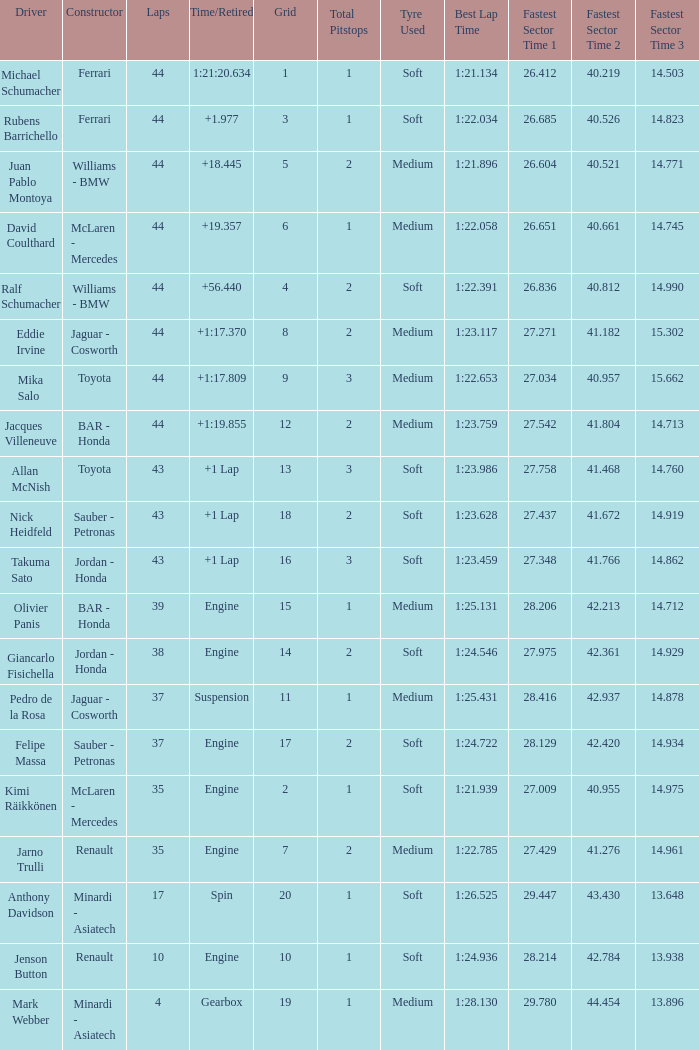What was the fewest laps for somone who finished +18.445? 44.0. 